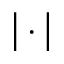<formula> <loc_0><loc_0><loc_500><loc_500>\left | \cdot \right |</formula> 